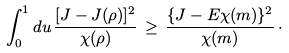Convert formula to latex. <formula><loc_0><loc_0><loc_500><loc_500>\int _ { 0 } ^ { 1 } d u \, \frac { [ J - J ( \rho ) ] ^ { 2 } } { \chi ( \rho ) } \, \geq \, \frac { \{ J - E \chi ( m ) \} ^ { 2 } } { \chi ( m ) } \, \cdot</formula> 